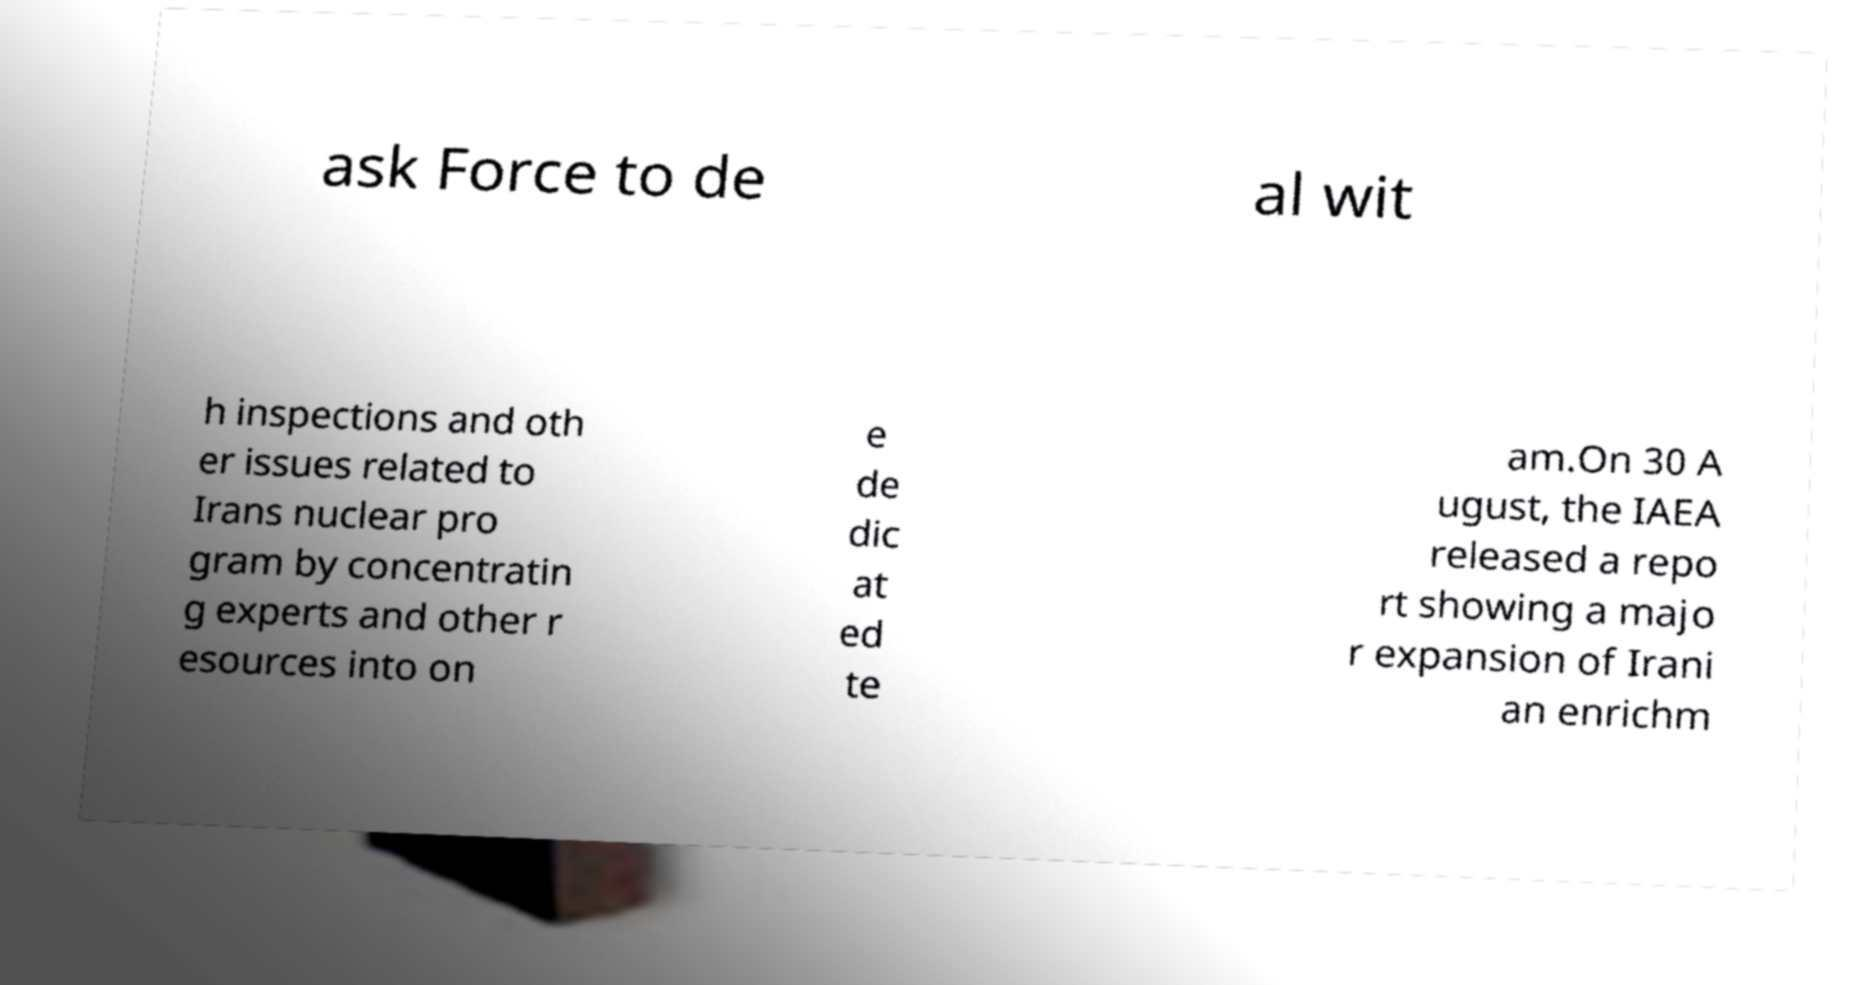For documentation purposes, I need the text within this image transcribed. Could you provide that? ask Force to de al wit h inspections and oth er issues related to Irans nuclear pro gram by concentratin g experts and other r esources into on e de dic at ed te am.On 30 A ugust, the IAEA released a repo rt showing a majo r expansion of Irani an enrichm 